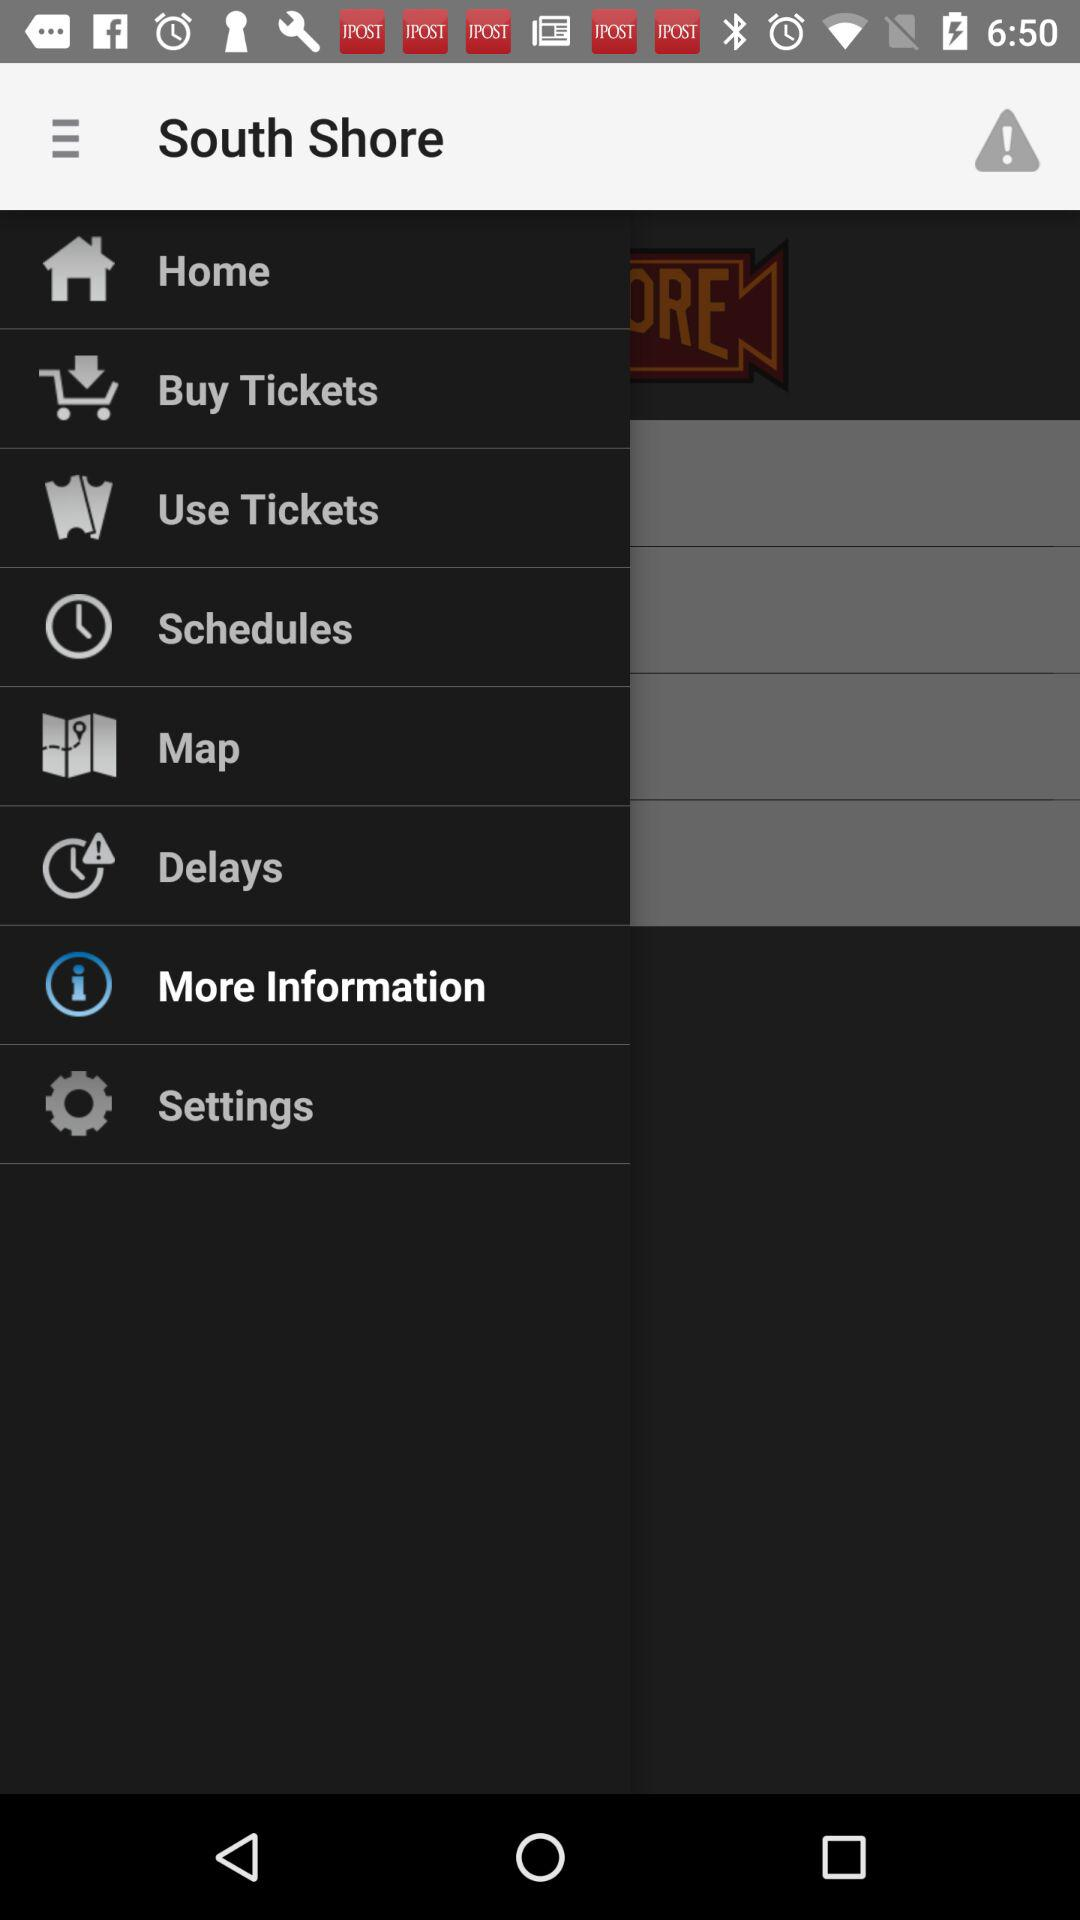Which item is selected? The selected item is "More Information". 